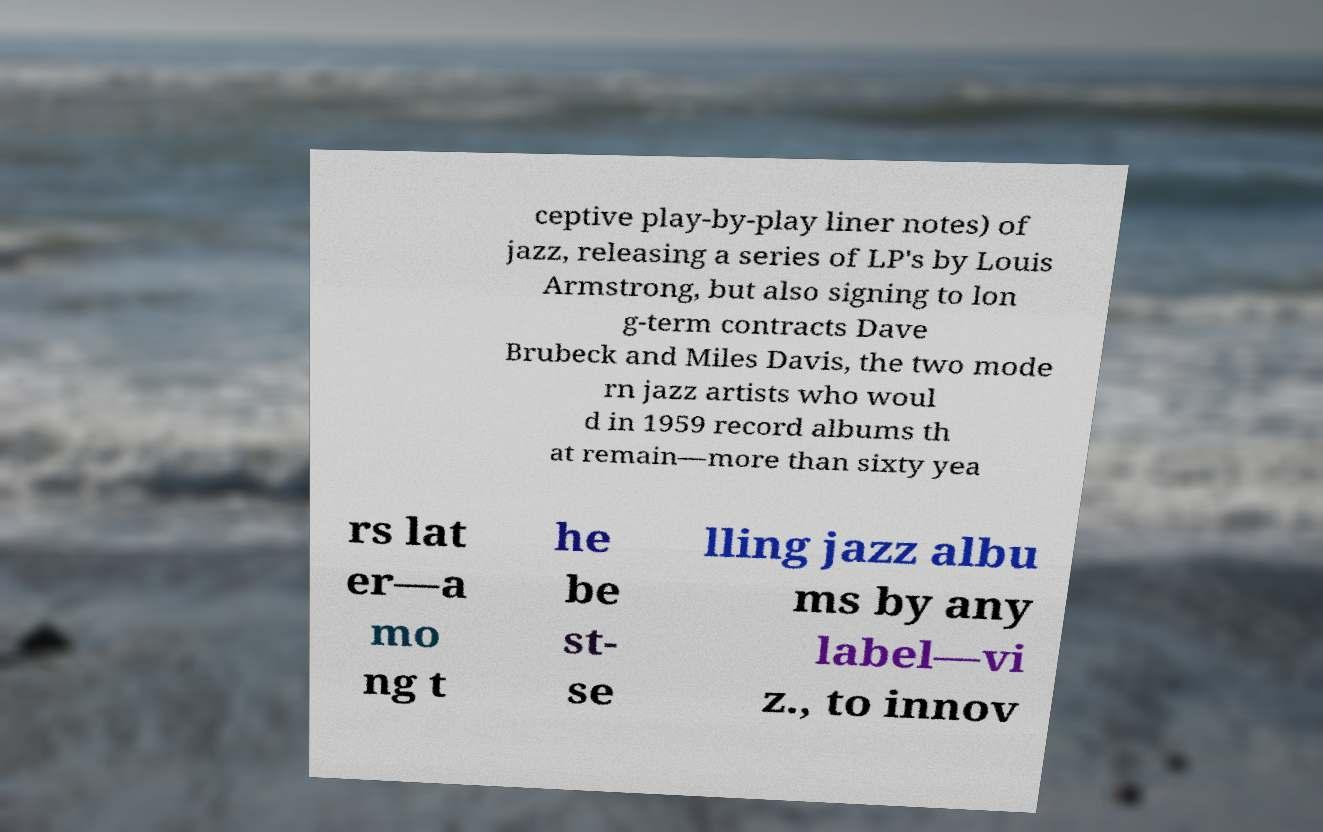Could you assist in decoding the text presented in this image and type it out clearly? ceptive play-by-play liner notes) of jazz, releasing a series of LP's by Louis Armstrong, but also signing to lon g-term contracts Dave Brubeck and Miles Davis, the two mode rn jazz artists who woul d in 1959 record albums th at remain—more than sixty yea rs lat er—a mo ng t he be st- se lling jazz albu ms by any label—vi z., to innov 